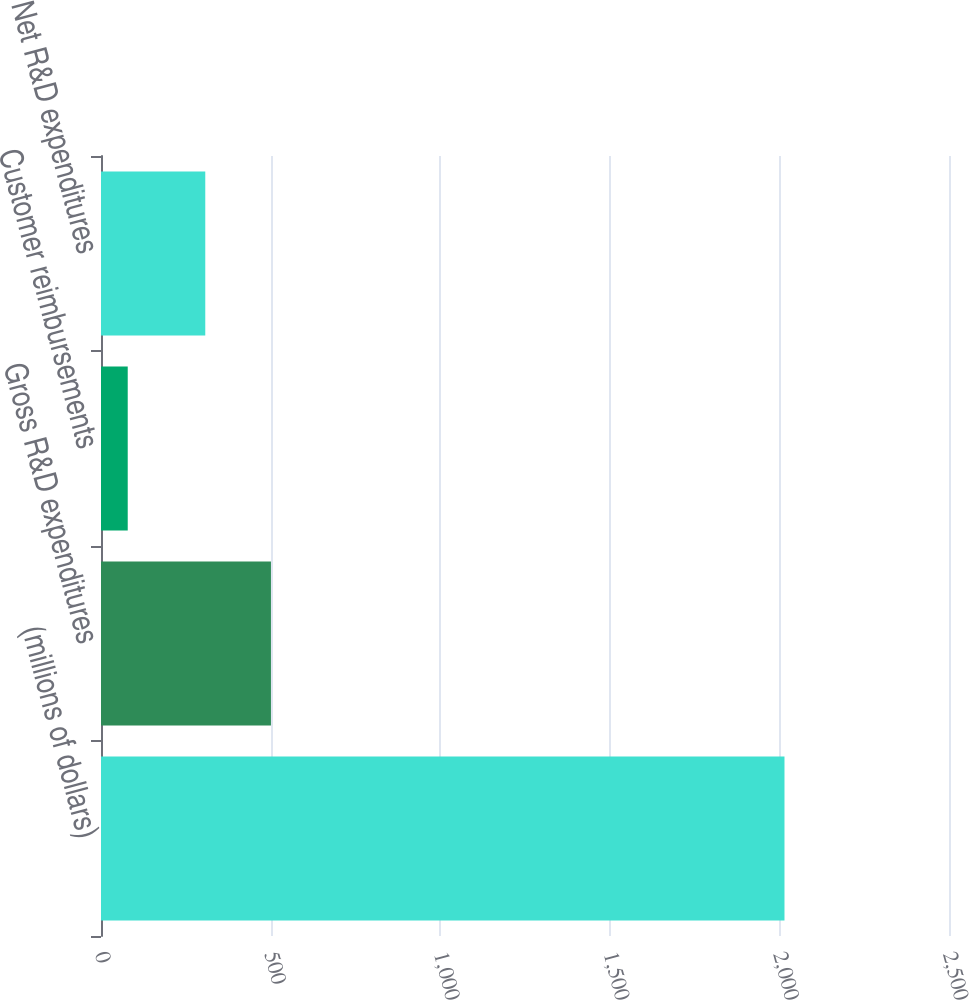<chart> <loc_0><loc_0><loc_500><loc_500><bar_chart><fcel>(millions of dollars)<fcel>Gross R&D expenditures<fcel>Customer reimbursements<fcel>Net R&D expenditures<nl><fcel>2015<fcel>501.02<fcel>78.8<fcel>307.4<nl></chart> 